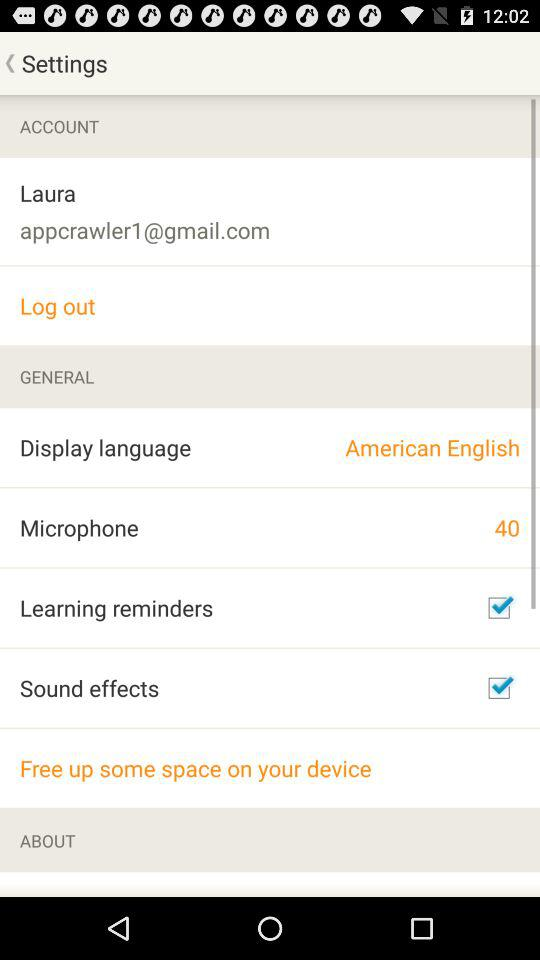What is the name of the user? The name of the user is Laura. 